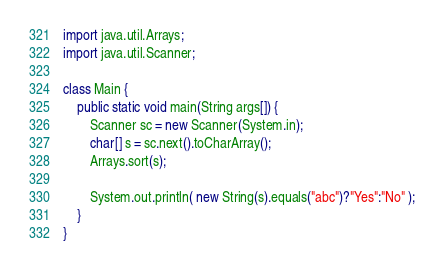Convert code to text. <code><loc_0><loc_0><loc_500><loc_500><_Java_>import java.util.Arrays;
import java.util.Scanner;

class Main {
    public static void main(String args[]) {
        Scanner sc = new Scanner(System.in);
        char[] s = sc.next().toCharArray();
        Arrays.sort(s);

        System.out.println( new String(s).equals("abc")?"Yes":"No" );
    }
}
</code> 